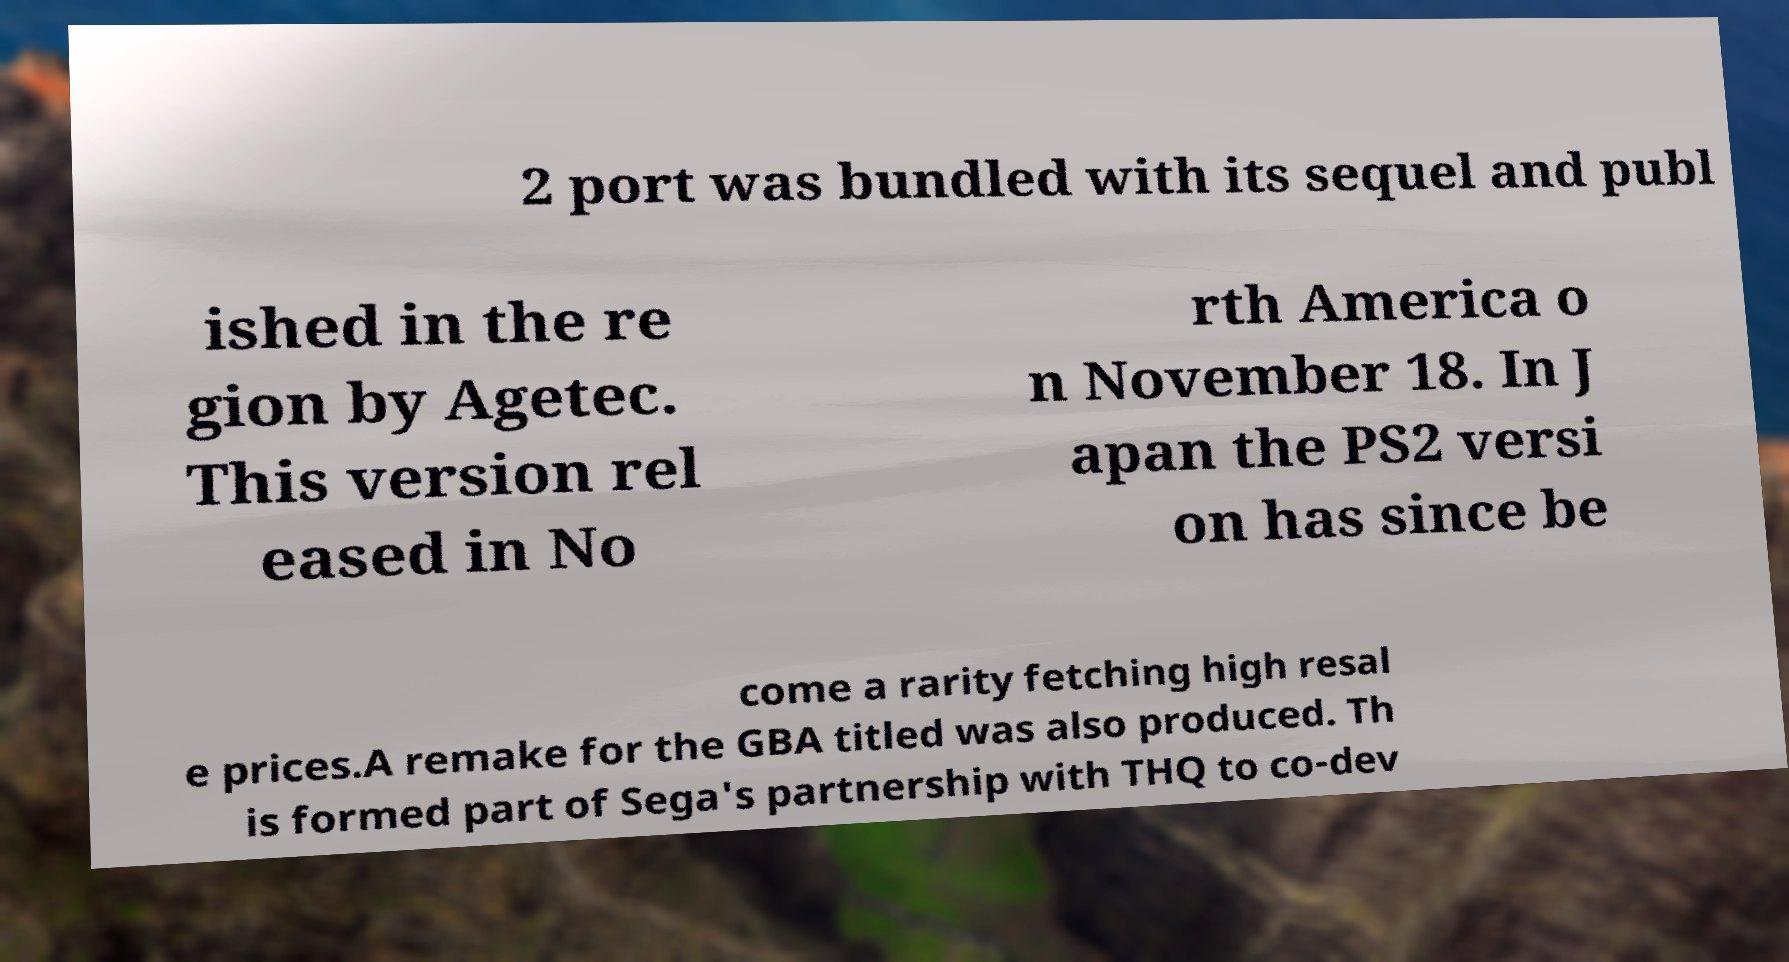Could you extract and type out the text from this image? 2 port was bundled with its sequel and publ ished in the re gion by Agetec. This version rel eased in No rth America o n November 18. In J apan the PS2 versi on has since be come a rarity fetching high resal e prices.A remake for the GBA titled was also produced. Th is formed part of Sega's partnership with THQ to co-dev 